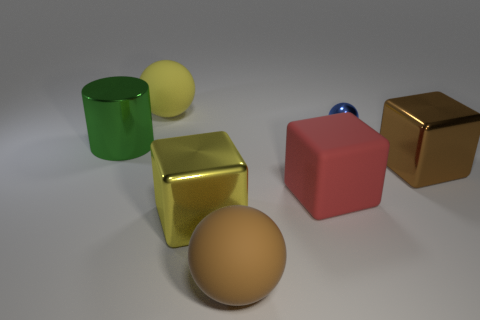Is there anything else that has the same color as the shiny cylinder?
Your response must be concise. No. What number of other things are the same size as the metal sphere?
Offer a terse response. 0. There is a large thing that is on the right side of the small blue shiny object; does it have the same shape as the big yellow metal object?
Offer a terse response. Yes. What number of other things are there of the same shape as the small blue metal thing?
Make the answer very short. 2. The large rubber object behind the large metallic cylinder has what shape?
Keep it short and to the point. Sphere. Is there another ball that has the same material as the brown ball?
Make the answer very short. Yes. The green cylinder is what size?
Your answer should be very brief. Large. There is a shiny cube left of the big cube that is behind the matte cube; are there any large green metallic cylinders that are behind it?
Give a very brief answer. Yes. How many big red objects are right of the cylinder?
Offer a very short reply. 1. What number of things are objects that are behind the big brown cube or rubber balls that are on the left side of the yellow metallic thing?
Your answer should be very brief. 3. 